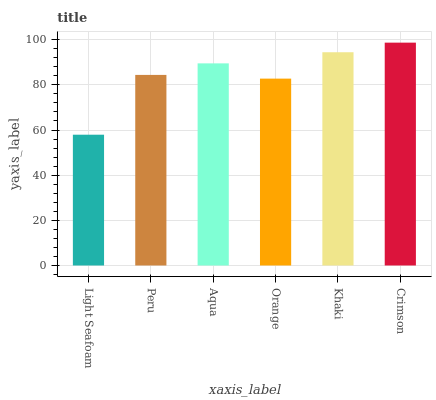Is Light Seafoam the minimum?
Answer yes or no. Yes. Is Crimson the maximum?
Answer yes or no. Yes. Is Peru the minimum?
Answer yes or no. No. Is Peru the maximum?
Answer yes or no. No. Is Peru greater than Light Seafoam?
Answer yes or no. Yes. Is Light Seafoam less than Peru?
Answer yes or no. Yes. Is Light Seafoam greater than Peru?
Answer yes or no. No. Is Peru less than Light Seafoam?
Answer yes or no. No. Is Aqua the high median?
Answer yes or no. Yes. Is Peru the low median?
Answer yes or no. Yes. Is Crimson the high median?
Answer yes or no. No. Is Aqua the low median?
Answer yes or no. No. 